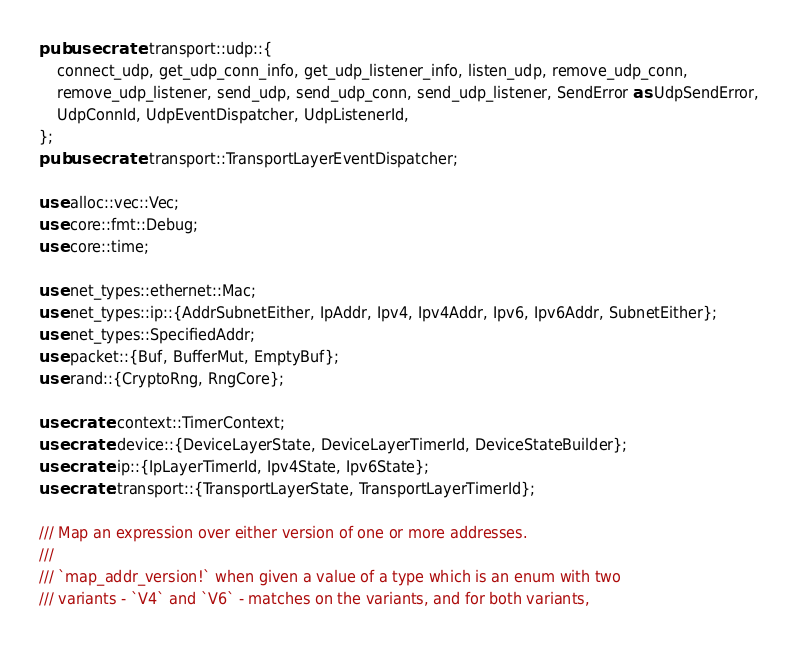Convert code to text. <code><loc_0><loc_0><loc_500><loc_500><_Rust_>pub use crate::transport::udp::{
    connect_udp, get_udp_conn_info, get_udp_listener_info, listen_udp, remove_udp_conn,
    remove_udp_listener, send_udp, send_udp_conn, send_udp_listener, SendError as UdpSendError,
    UdpConnId, UdpEventDispatcher, UdpListenerId,
};
pub use crate::transport::TransportLayerEventDispatcher;

use alloc::vec::Vec;
use core::fmt::Debug;
use core::time;

use net_types::ethernet::Mac;
use net_types::ip::{AddrSubnetEither, IpAddr, Ipv4, Ipv4Addr, Ipv6, Ipv6Addr, SubnetEither};
use net_types::SpecifiedAddr;
use packet::{Buf, BufferMut, EmptyBuf};
use rand::{CryptoRng, RngCore};

use crate::context::TimerContext;
use crate::device::{DeviceLayerState, DeviceLayerTimerId, DeviceStateBuilder};
use crate::ip::{IpLayerTimerId, Ipv4State, Ipv6State};
use crate::transport::{TransportLayerState, TransportLayerTimerId};

/// Map an expression over either version of one or more addresses.
///
/// `map_addr_version!` when given a value of a type which is an enum with two
/// variants - `V4` and `V6` - matches on the variants, and for both variants,</code> 